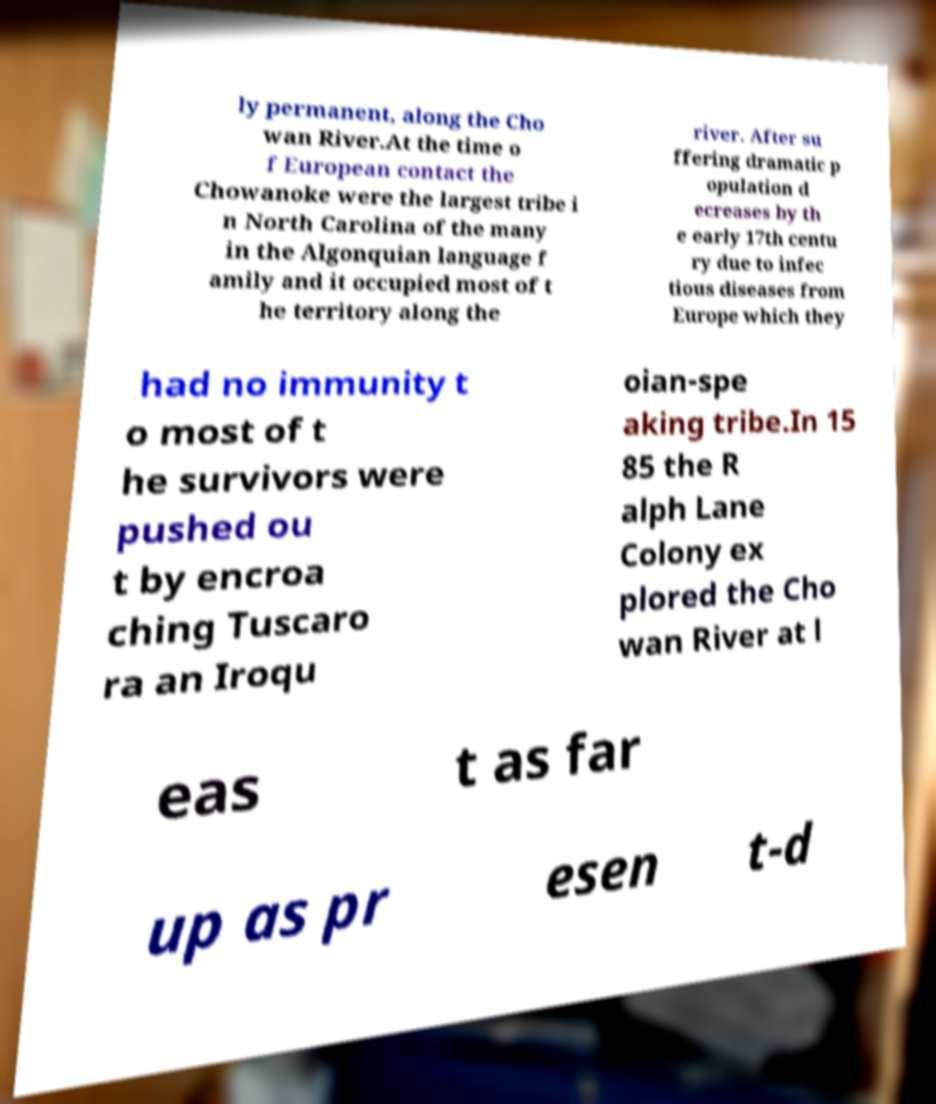Can you read and provide the text displayed in the image?This photo seems to have some interesting text. Can you extract and type it out for me? ly permanent, along the Cho wan River.At the time o f European contact the Chowanoke were the largest tribe i n North Carolina of the many in the Algonquian language f amily and it occupied most of t he territory along the river. After su ffering dramatic p opulation d ecreases by th e early 17th centu ry due to infec tious diseases from Europe which they had no immunity t o most of t he survivors were pushed ou t by encroa ching Tuscaro ra an Iroqu oian-spe aking tribe.In 15 85 the R alph Lane Colony ex plored the Cho wan River at l eas t as far up as pr esen t-d 